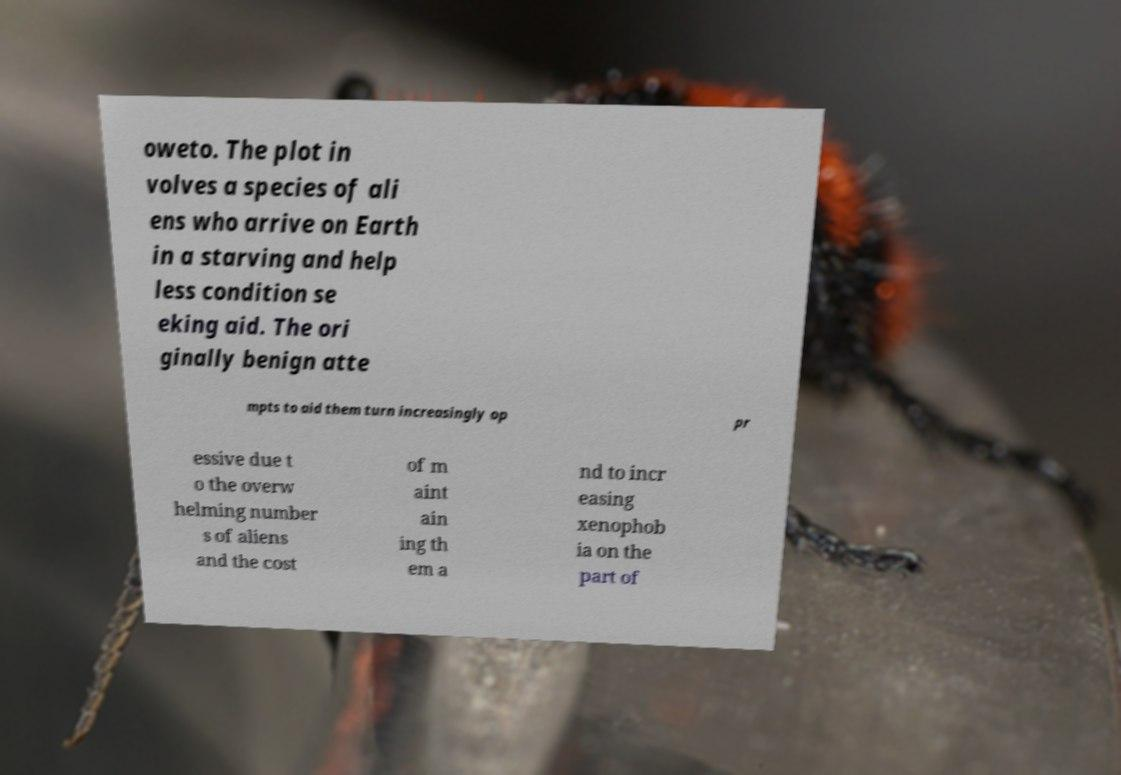Could you extract and type out the text from this image? oweto. The plot in volves a species of ali ens who arrive on Earth in a starving and help less condition se eking aid. The ori ginally benign atte mpts to aid them turn increasingly op pr essive due t o the overw helming number s of aliens and the cost of m aint ain ing th em a nd to incr easing xenophob ia on the part of 